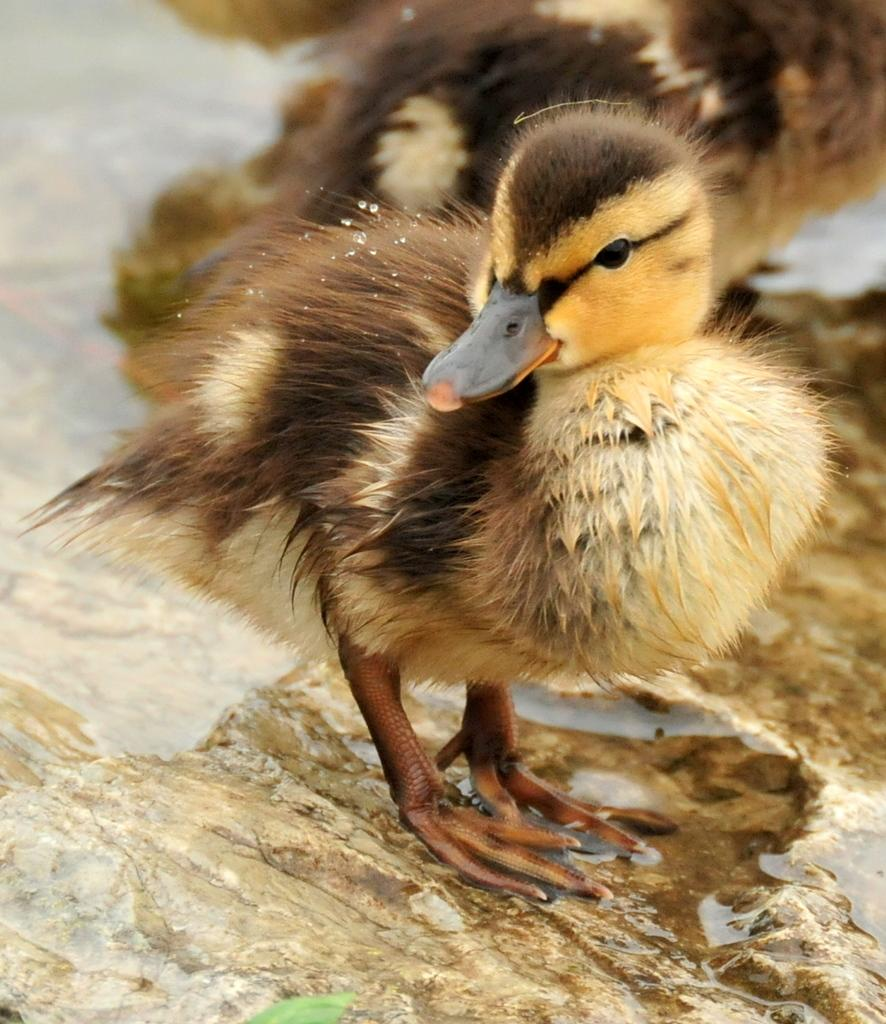What animal is in the middle of the image? There is a duckling in the middle of the image. What can be seen on the left side of the image? There is water on the left side of the image. What type of yoke is being used by the duckling in the image? There is no yoke present in the image, as it features a duckling in water. What brand of toothpaste is visible in the image? There is no toothpaste present in the image; it features a duckling in water. 